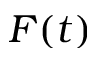<formula> <loc_0><loc_0><loc_500><loc_500>F ( t )</formula> 